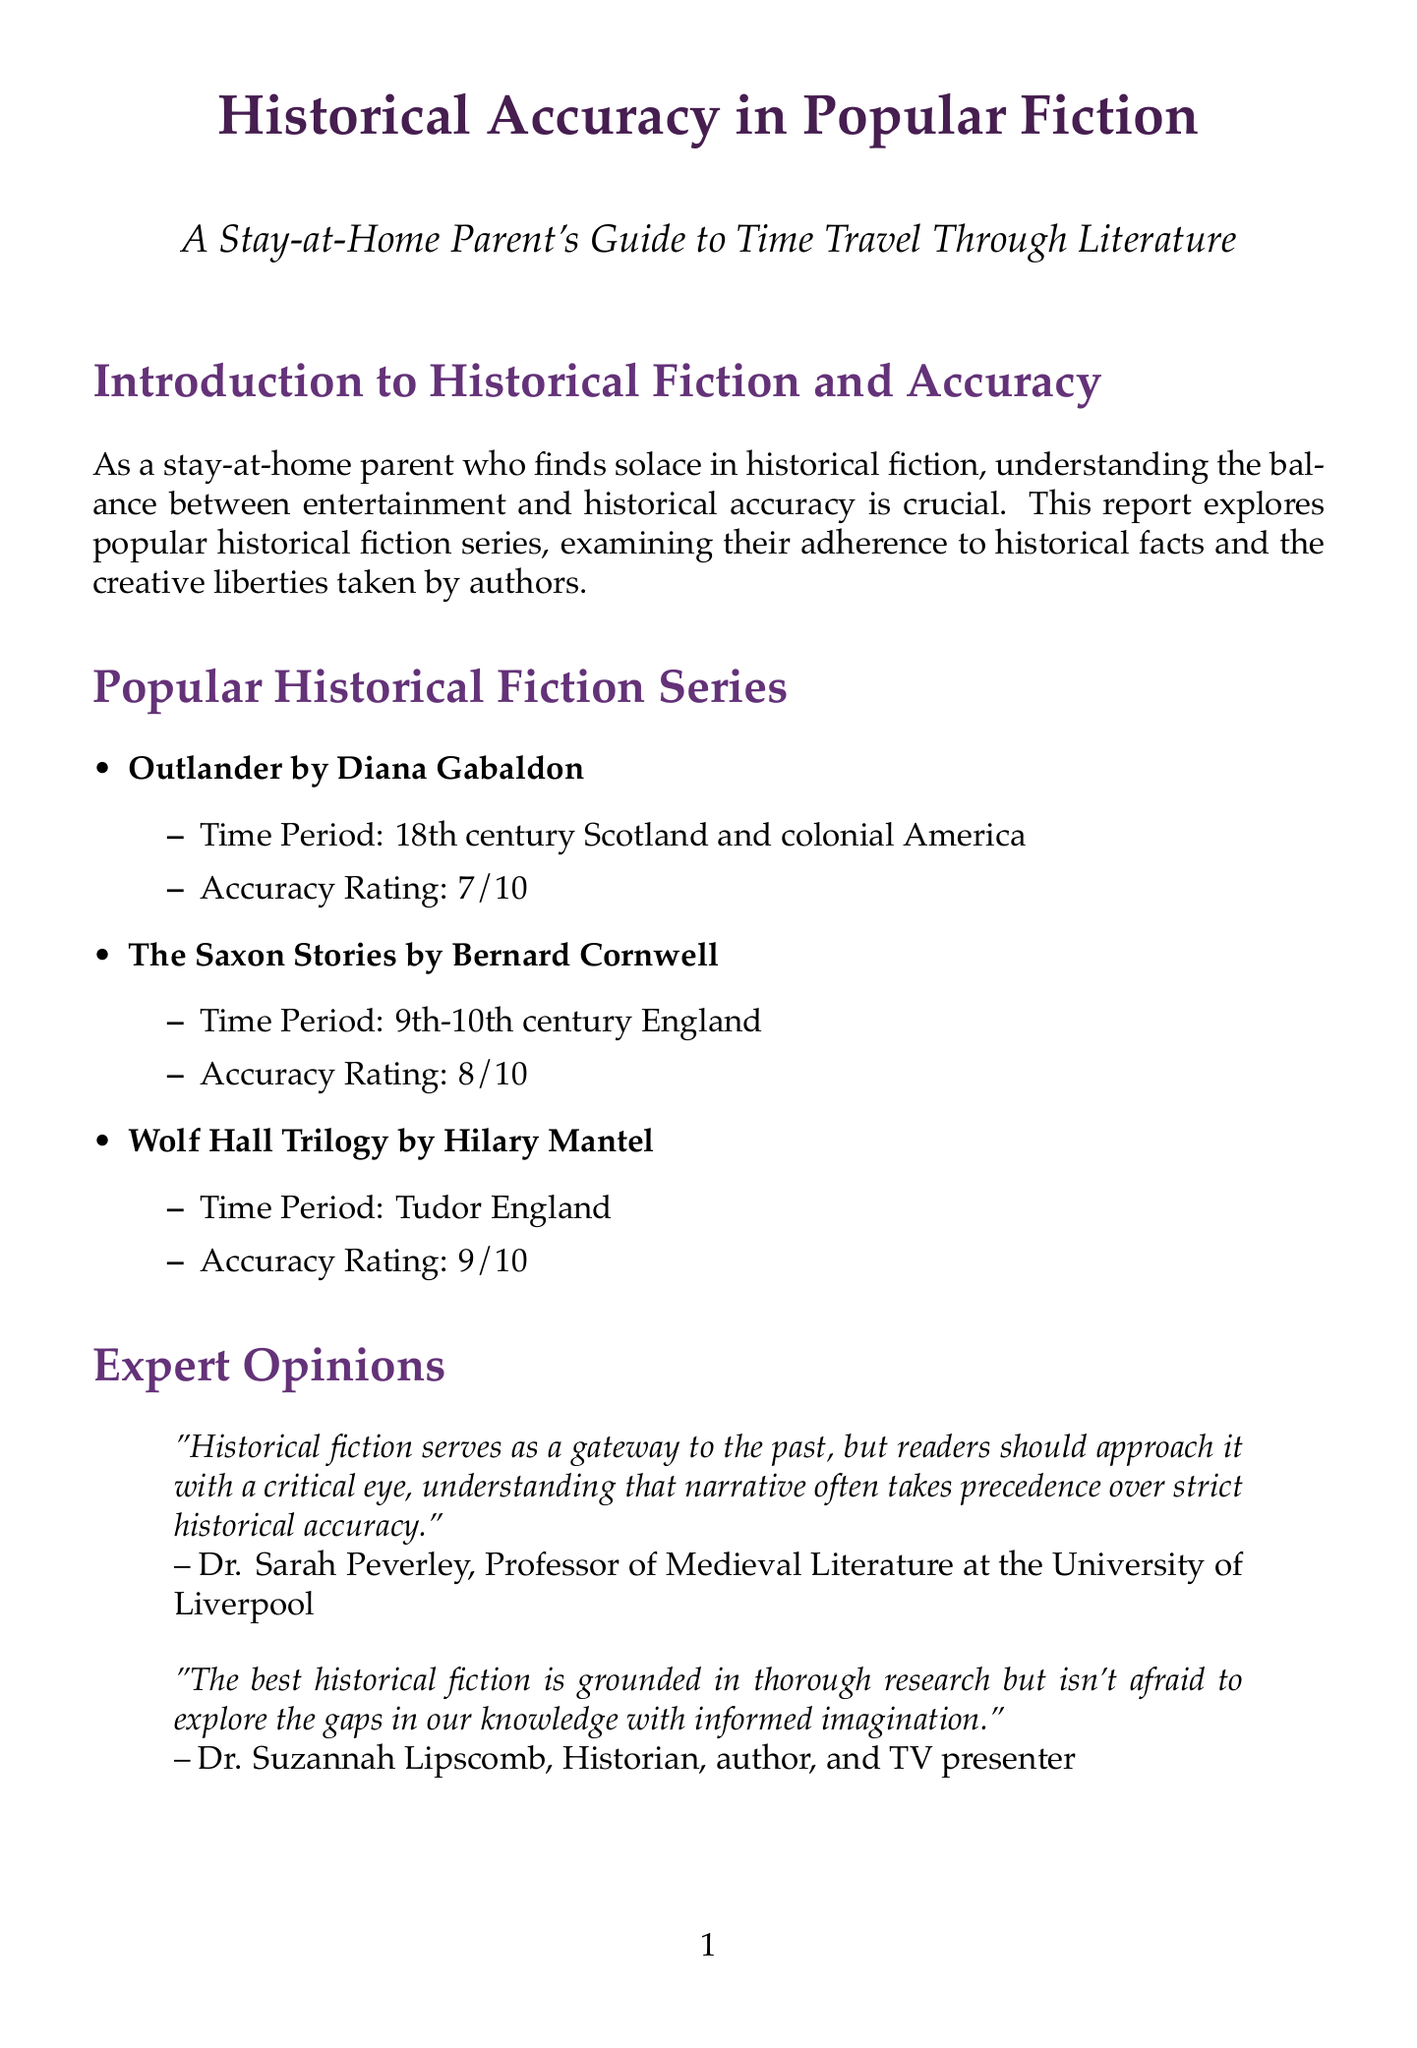What is the accuracy rating of Outlander? The accuracy rating for Outlander is provided in the document, which is 7 out of 10.
Answer: 7/10 What time period does The Saxon Stories cover? The document specifies that The Saxon Stories takes place in the 9th-10th century England.
Answer: 9th-10th century England Who is the author of the Wolf Hall Trilogy? The document lists Hilary Mantel as the author of the Wolf Hall Trilogy.
Answer: Hilary Mantel What is one strength of Outlander? The report discusses the strengths of Outlander, specifically mentioning its accurate portrayal of Scottish clan culture and the Jacobite uprising.
Answer: Accurate portrayal of 18th-century Scottish clan culture and Jacobite uprising What unique aspect of historical fiction does Dr. Sarah Peverley highlight? Dr. Sarah Peverley emphasizes the importance of approaching historical fiction with a critical eye.
Answer: Narrative takes precedence over strict historical accuracy What is the purpose of this report? The document introduces the report's aim, which is to explore historical fiction series and their adherence to historical facts.
Answer: Examining adherence to historical facts What resource discusses interviews with historians? The document lists resources for further learning, mentioning the HistoryExtra Podcast as one that features historian interviews.
Answer: HistoryExtra Podcast What is a weakness noted in The Saxon Stories? The report provides insight into The Saxon Stories, identifying timeline compression as a noted weakness.
Answer: Some liberties taken with timeline compression 